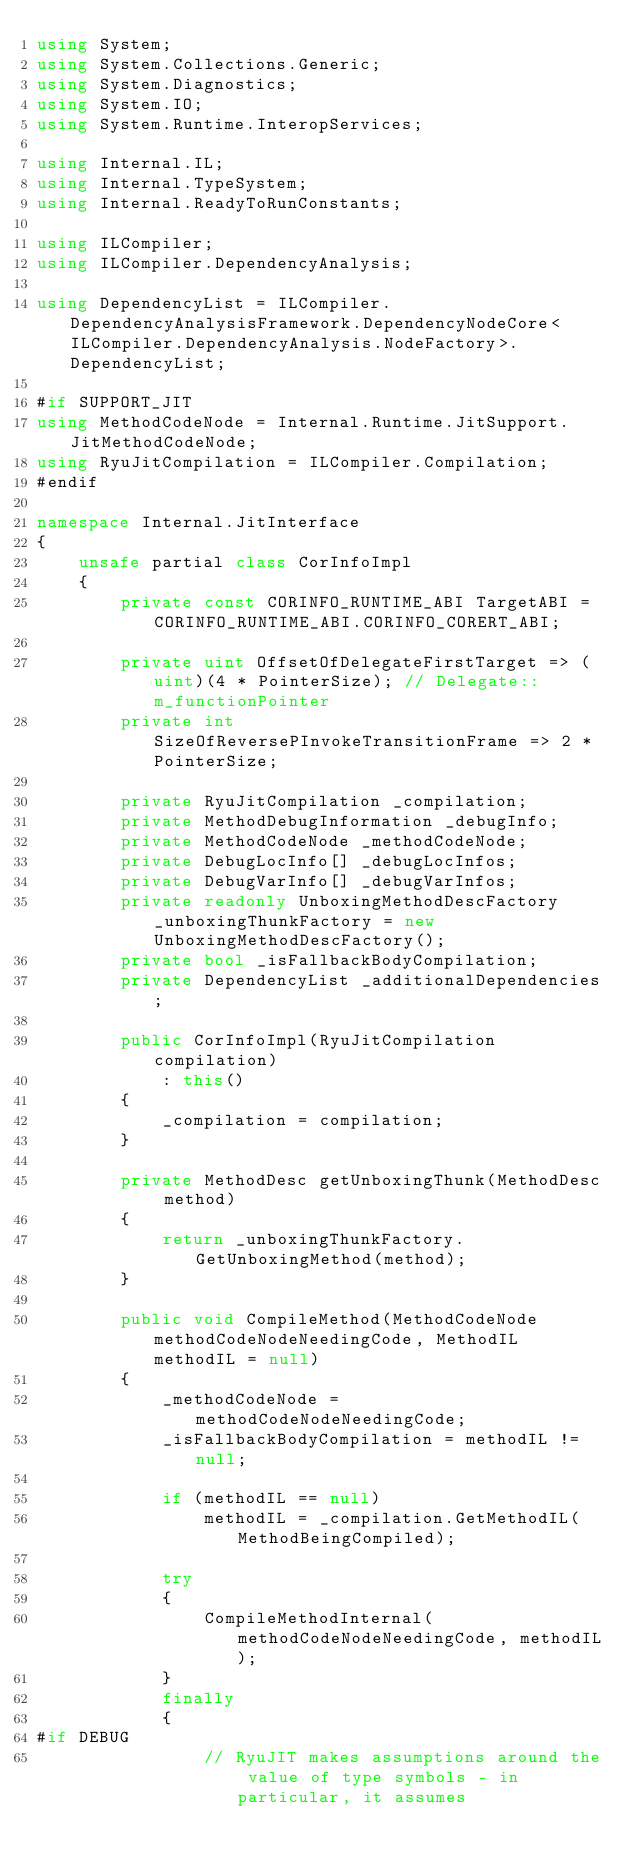<code> <loc_0><loc_0><loc_500><loc_500><_C#_>using System;
using System.Collections.Generic;
using System.Diagnostics;
using System.IO;
using System.Runtime.InteropServices;

using Internal.IL;
using Internal.TypeSystem;
using Internal.ReadyToRunConstants;

using ILCompiler;
using ILCompiler.DependencyAnalysis;

using DependencyList = ILCompiler.DependencyAnalysisFramework.DependencyNodeCore<ILCompiler.DependencyAnalysis.NodeFactory>.DependencyList;

#if SUPPORT_JIT
using MethodCodeNode = Internal.Runtime.JitSupport.JitMethodCodeNode;
using RyuJitCompilation = ILCompiler.Compilation;
#endif

namespace Internal.JitInterface
{
    unsafe partial class CorInfoImpl
    {
        private const CORINFO_RUNTIME_ABI TargetABI = CORINFO_RUNTIME_ABI.CORINFO_CORERT_ABI;

        private uint OffsetOfDelegateFirstTarget => (uint)(4 * PointerSize); // Delegate::m_functionPointer
        private int SizeOfReversePInvokeTransitionFrame => 2 * PointerSize;

        private RyuJitCompilation _compilation;
        private MethodDebugInformation _debugInfo;
        private MethodCodeNode _methodCodeNode;
        private DebugLocInfo[] _debugLocInfos;
        private DebugVarInfo[] _debugVarInfos;
        private readonly UnboxingMethodDescFactory _unboxingThunkFactory = new UnboxingMethodDescFactory();
        private bool _isFallbackBodyCompilation;
        private DependencyList _additionalDependencies;

        public CorInfoImpl(RyuJitCompilation compilation)
            : this()
        {
            _compilation = compilation;
        }

        private MethodDesc getUnboxingThunk(MethodDesc method)
        {
            return _unboxingThunkFactory.GetUnboxingMethod(method);
        }

        public void CompileMethod(MethodCodeNode methodCodeNodeNeedingCode, MethodIL methodIL = null)
        {
            _methodCodeNode = methodCodeNodeNeedingCode;
            _isFallbackBodyCompilation = methodIL != null;

            if (methodIL == null)
                methodIL = _compilation.GetMethodIL(MethodBeingCompiled);

            try
            {
                CompileMethodInternal(methodCodeNodeNeedingCode, methodIL);
            }
            finally
            {
#if DEBUG
                // RyuJIT makes assumptions around the value of type symbols - in particular, it assumes</code> 